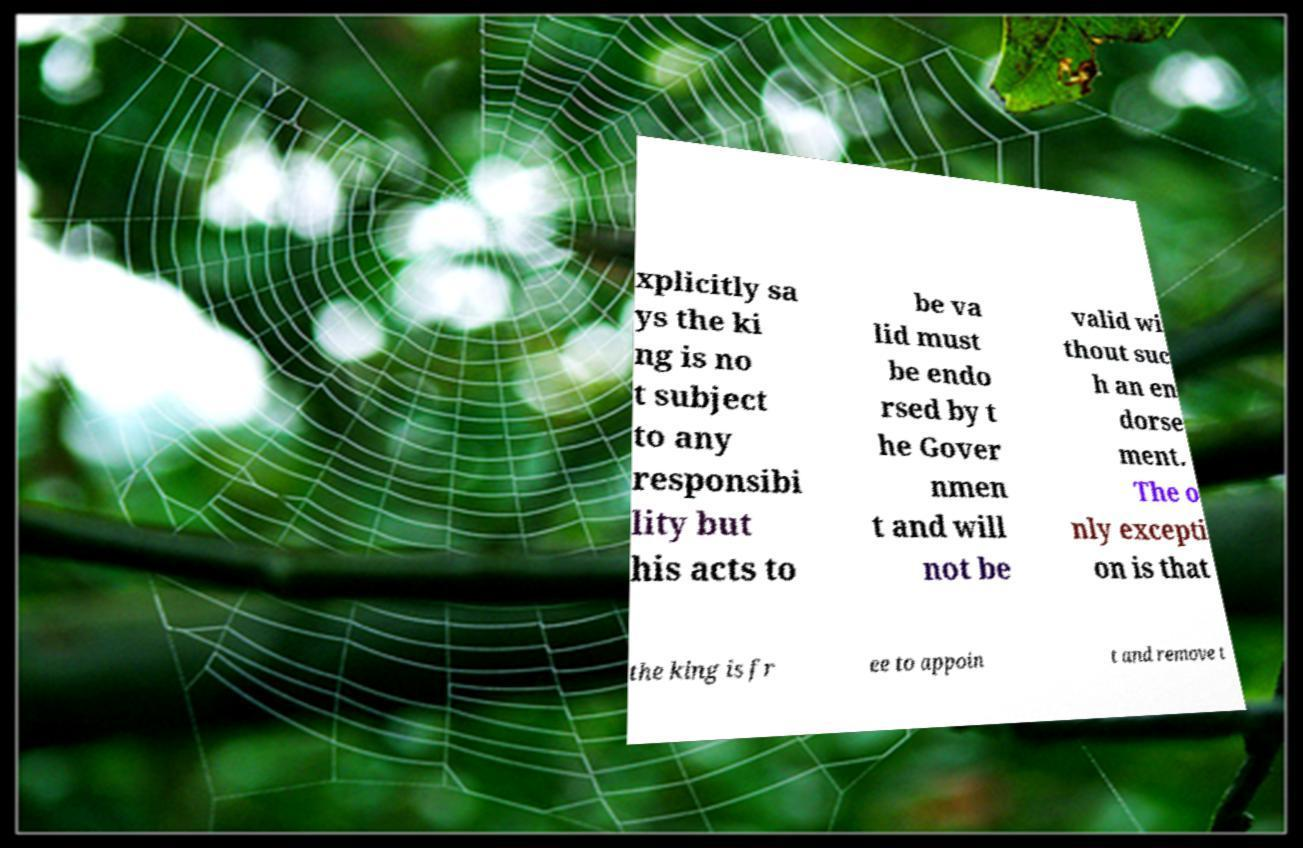There's text embedded in this image that I need extracted. Can you transcribe it verbatim? xplicitly sa ys the ki ng is no t subject to any responsibi lity but his acts to be va lid must be endo rsed by t he Gover nmen t and will not be valid wi thout suc h an en dorse ment. The o nly excepti on is that the king is fr ee to appoin t and remove t 